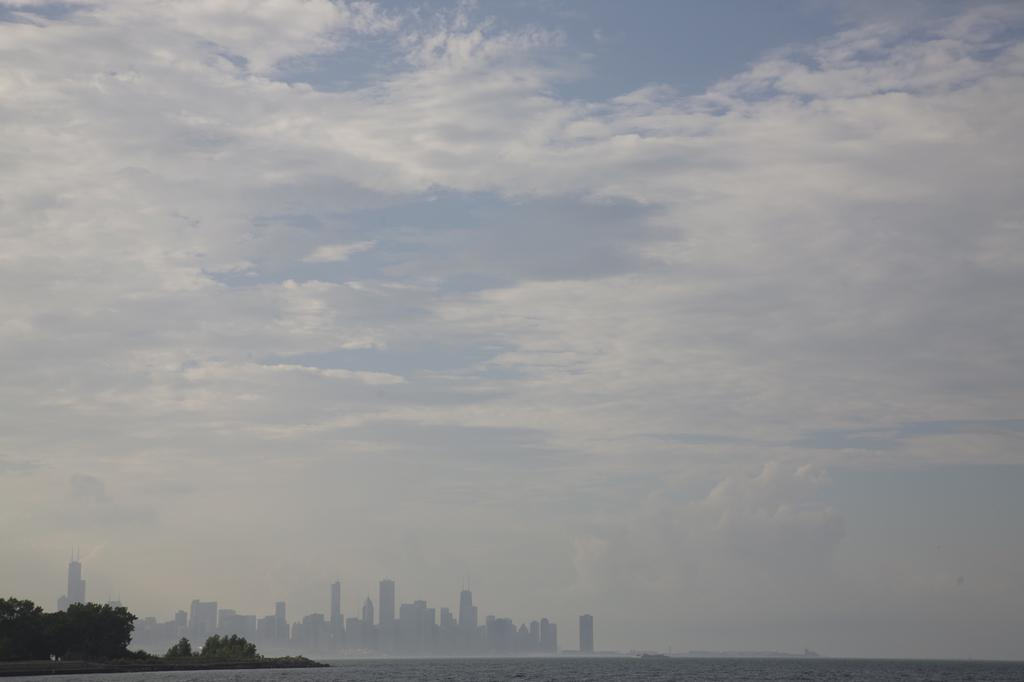What is the condition of the sky in the image? The sky in the image is cloudy. What can be seen at the bottom of the image? Water, trees, and buildings are visible at the bottom of the image. What type of loaf is being exchanged between the trees in the image? There is no loaf or exchange present in the image; it features a cloudy sky, water, trees, and buildings. 